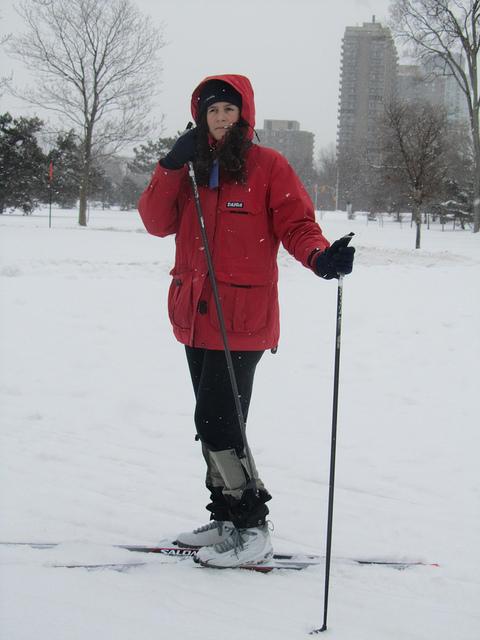What color are her mittens?
Concise answer only. Black. Is the person a man or woman?
Write a very short answer. Woman. What Color is the person's coat?
Concise answer only. Red. Is it snowing?
Concise answer only. Yes. How many ski poles is the person holding?
Concise answer only. 2. Is the skier a boy or a girl?
Answer briefly. Girl. 